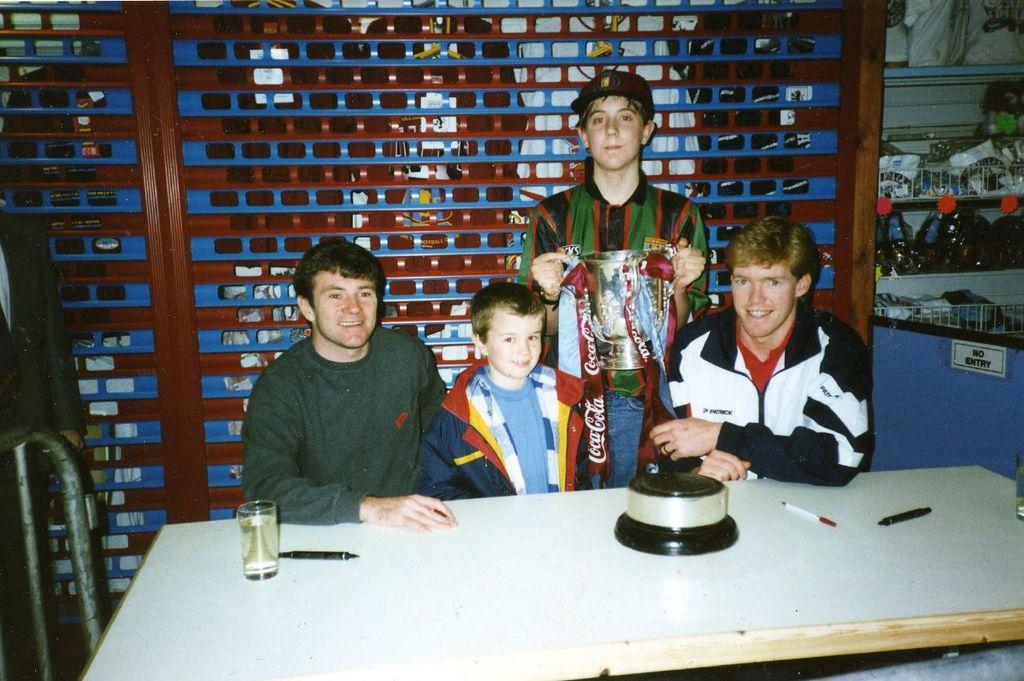How many people are sitting in the image? There are three men sitting on chairs in the image. What is the standing person doing? The standing person is holding a cup in their hand. What objects can be found on the table? There are pens and a glass on the table. What is the name of the friend who is not present in the image? There is no mention of a friend in the image, so it is not possible to determine their name. 